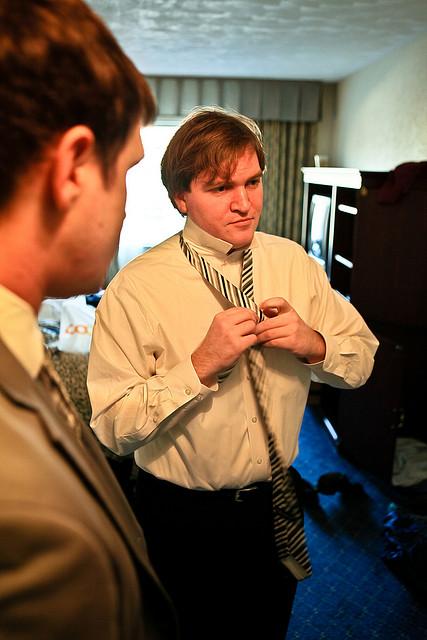What type of building are these men in?
Quick response, please. Hotel. Are the eyes closed on the man with a tie?
Give a very brief answer. No. Does this man have cufflinks on?
Short answer required. No. Why is the man's face have a serious expression?
Write a very short answer. Concentrating. What pattern is his tie?
Short answer required. Striped. 